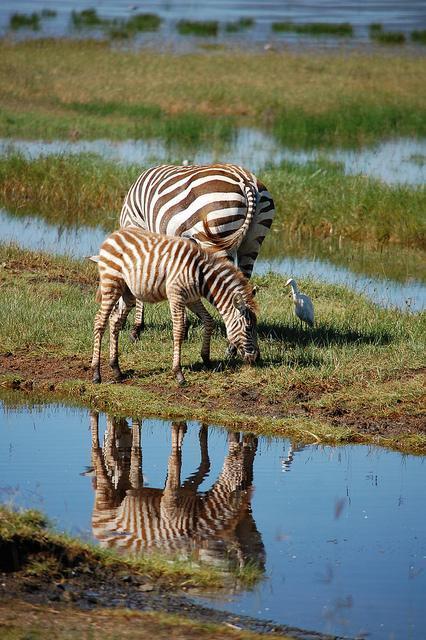How many animals are in the picture?
Give a very brief answer. 3. How many zebra are in this picture?
Give a very brief answer. 2. How many zebras are visible?
Give a very brief answer. 2. 